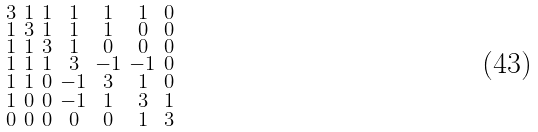Convert formula to latex. <formula><loc_0><loc_0><loc_500><loc_500>\begin{smallmatrix} 3 & 1 & 1 & 1 & 1 & 1 & 0 \\ 1 & 3 & 1 & 1 & 1 & 0 & 0 \\ 1 & 1 & 3 & 1 & 0 & 0 & 0 \\ 1 & 1 & 1 & 3 & - 1 & - 1 & 0 \\ 1 & 1 & 0 & - 1 & 3 & 1 & 0 \\ 1 & 0 & 0 & - 1 & 1 & 3 & 1 \\ 0 & 0 & 0 & 0 & 0 & 1 & 3 \end{smallmatrix}</formula> 